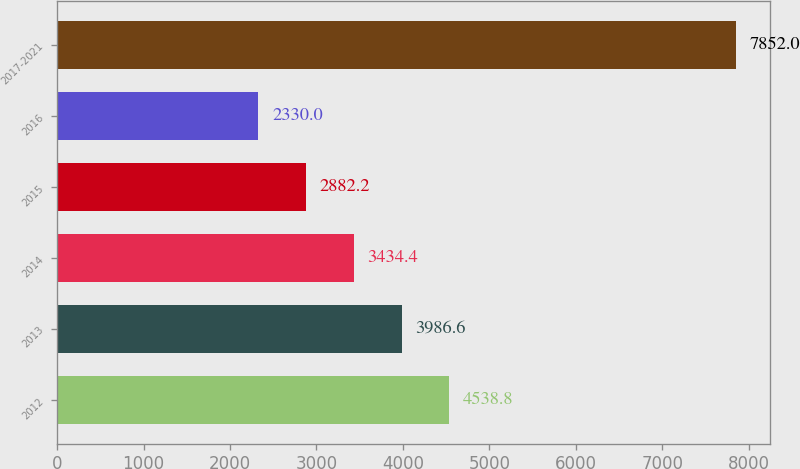Convert chart. <chart><loc_0><loc_0><loc_500><loc_500><bar_chart><fcel>2012<fcel>2013<fcel>2014<fcel>2015<fcel>2016<fcel>2017-2021<nl><fcel>4538.8<fcel>3986.6<fcel>3434.4<fcel>2882.2<fcel>2330<fcel>7852<nl></chart> 